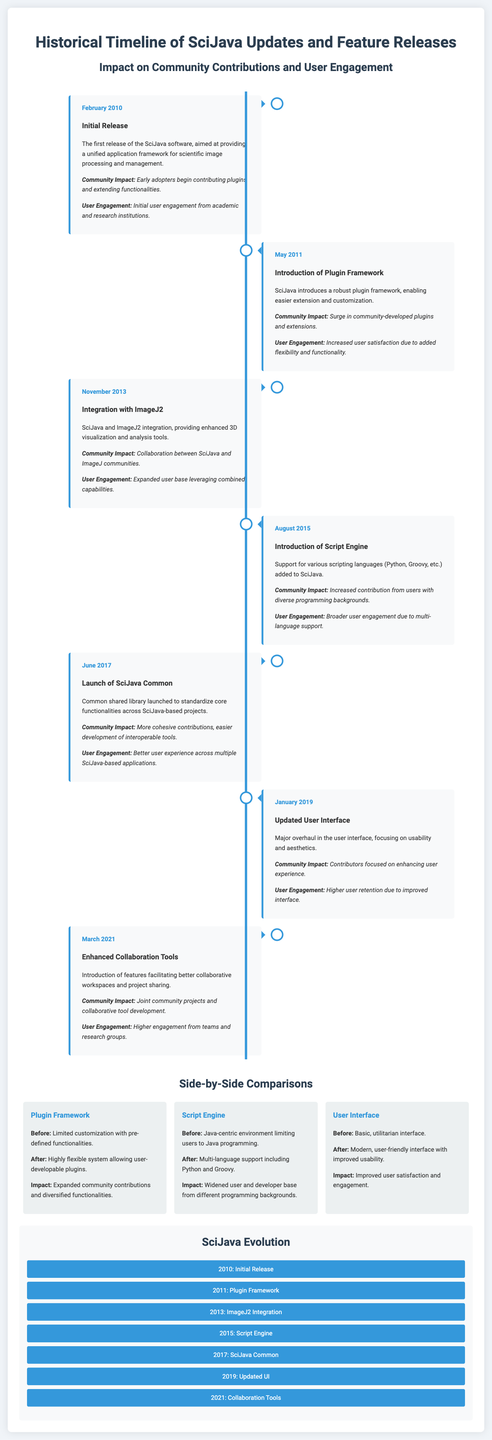what was the date of the initial release? The document specifies the date of the initial release as February 2010.
Answer: February 2010 what feature was introduced in May 2011? The document states that the introduction of the Plugin Framework occurred in May 2011.
Answer: Plugin Framework how did user engagement change after the introduction of the Script Engine? The document mentions that user engagement broadened due to multi-language support added with the Script Engine.
Answer: Broader user engagement what major update occurred in June 2017? The document lists the launch of SciJava Common as the major update in June 2017.
Answer: SciJava Common how many major updates took place between 2010 and 2021? The timeline in the document shows a total of seven significant events from 2010 to 2021.
Answer: Seven what is the impact of the updated user interface released in January 2019? According to the document, the impact of the updated user interface was higher user retention due to improved interface.
Answer: Higher user retention what is the main focus of the SciJava software as stated in the document? The document describes the main focus of SciJava as providing a unified application framework for scientific image processing and management.
Answer: Unified application framework what collaboration feature was introduced in March 2021? The document mentions the introduction of enhanced collaboration tools in March 2021.
Answer: Enhanced Collaboration Tools what type of comparison is made regarding the Plugin Framework? The document discusses a side-by-side comparison showing the impact of the Plugin Framework on customization flexibility.
Answer: Side-by-side comparison 